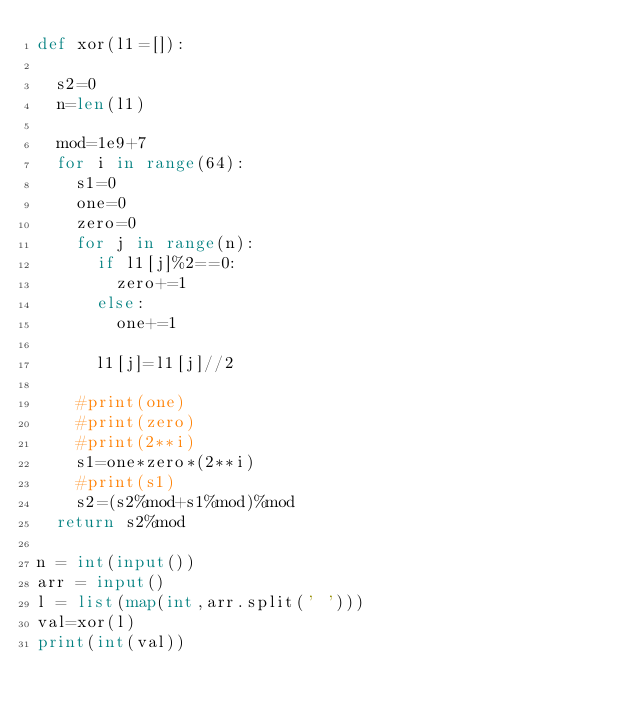<code> <loc_0><loc_0><loc_500><loc_500><_Python_>def xor(l1=[]):
  
  s2=0
  n=len(l1)

  mod=1e9+7
  for i in range(64):
    s1=0
    one=0
    zero=0
    for j in range(n):
      if l1[j]%2==0:
        zero+=1
      else:
        one+=1
      
      l1[j]=l1[j]//2

    #print(one)
    #print(zero)
    #print(2**i)
    s1=one*zero*(2**i)
    #print(s1)
    s2=(s2%mod+s1%mod)%mod
  return s2%mod

n = int(input())
arr = input()   
l = list(map(int,arr.split(' ')))
val=xor(l)
print(int(val))</code> 